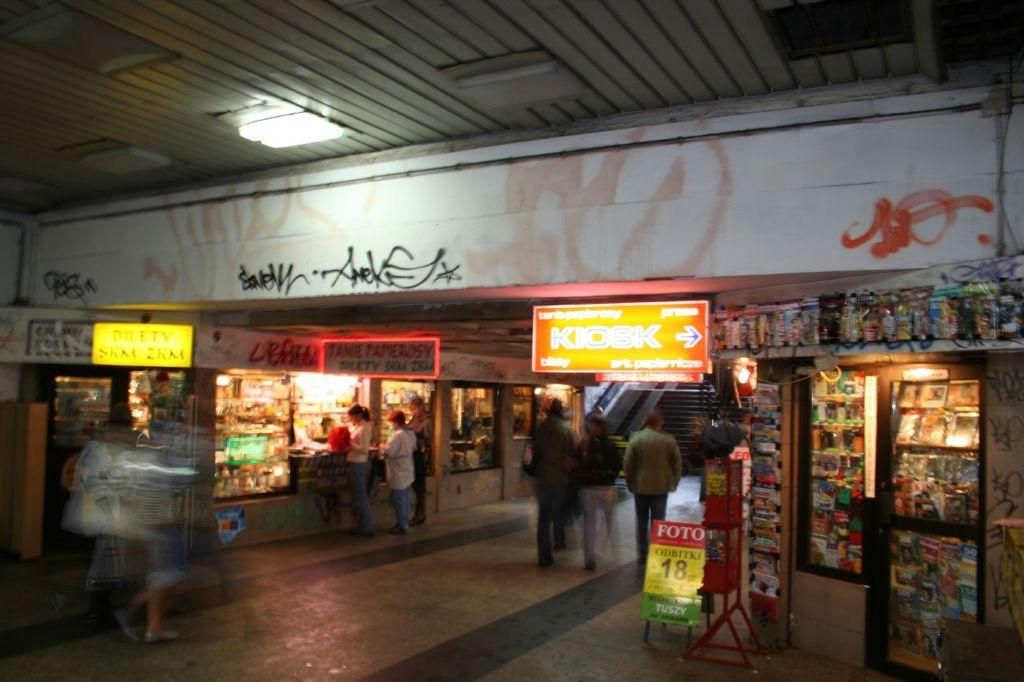Provide a one-sentence caption for the provided image. A bright orange sign shows the direction to the kiosk. 